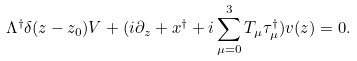Convert formula to latex. <formula><loc_0><loc_0><loc_500><loc_500>\Lambda ^ { \dagger } \delta ( z - z _ { 0 } ) V + ( i \partial _ { z } + x ^ { \dagger } + i \sum _ { \mu = 0 } ^ { 3 } T _ { \mu } \tau ^ { \dagger } _ { \mu } ) v ( z ) = 0 .</formula> 